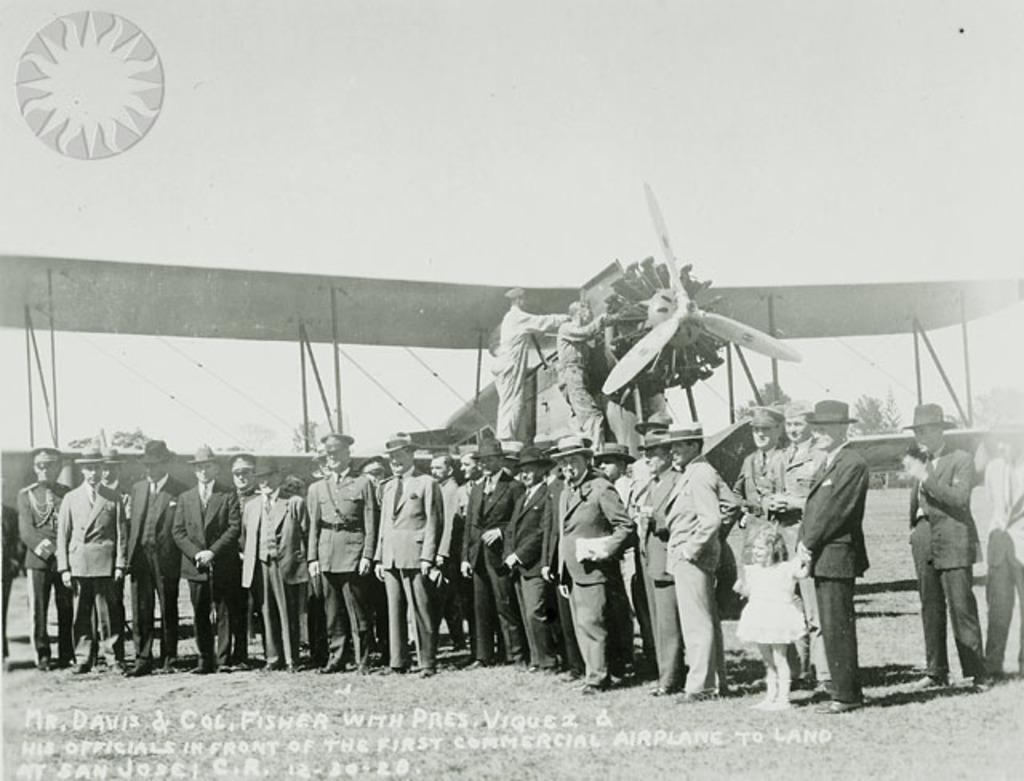<image>
Describe the image concisely. A picture of men with a prop airplane has writing at the bottom starting with Mr. Davis & Col. Fisher with Pres. Viquez. 